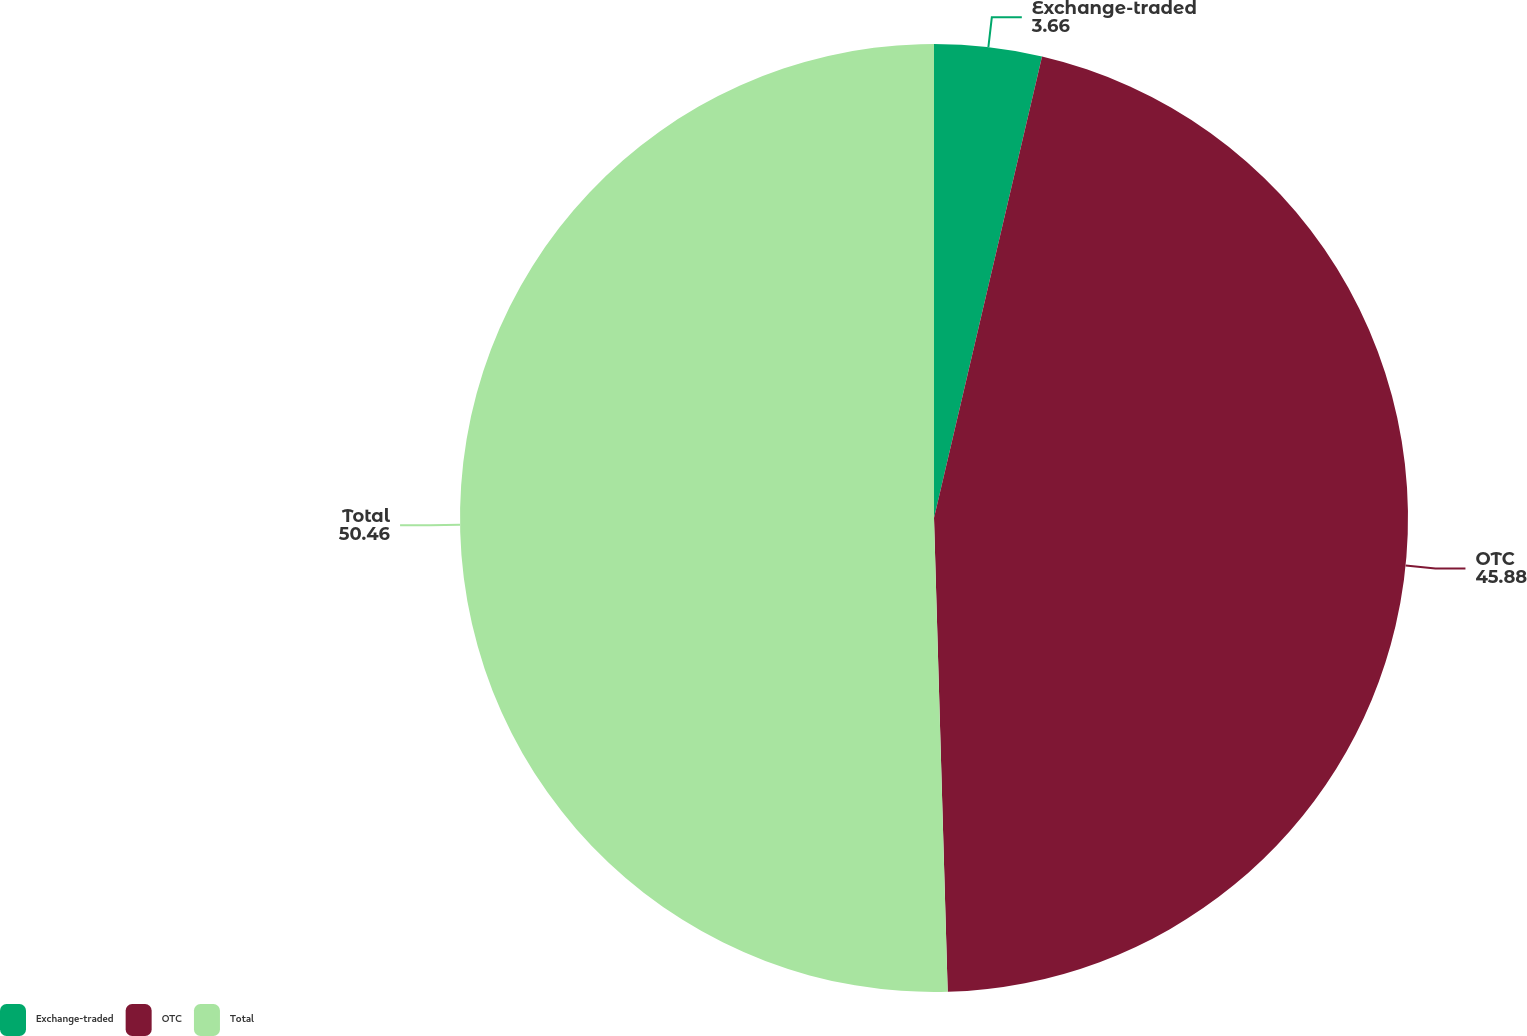Convert chart. <chart><loc_0><loc_0><loc_500><loc_500><pie_chart><fcel>Exchange-traded<fcel>OTC<fcel>Total<nl><fcel>3.66%<fcel>45.88%<fcel>50.46%<nl></chart> 